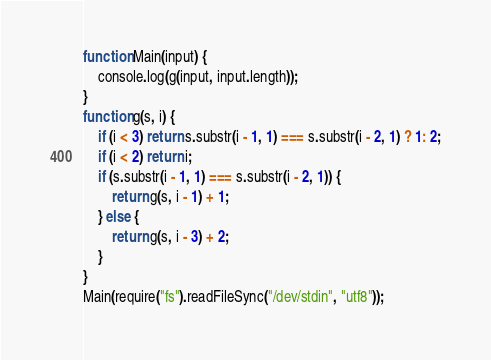<code> <loc_0><loc_0><loc_500><loc_500><_JavaScript_>function Main(input) {
	console.log(g(input, input.length));
}
function g(s, i) {
	if (i < 3) return s.substr(i - 1, 1) === s.substr(i - 2, 1) ? 1: 2;
	if (i < 2) return i;
	if (s.substr(i - 1, 1) === s.substr(i - 2, 1)) {
		return g(s, i - 1) + 1;
	} else {
		return g(s, i - 3) + 2;
	}
}
Main(require("fs").readFileSync("/dev/stdin", "utf8"));</code> 